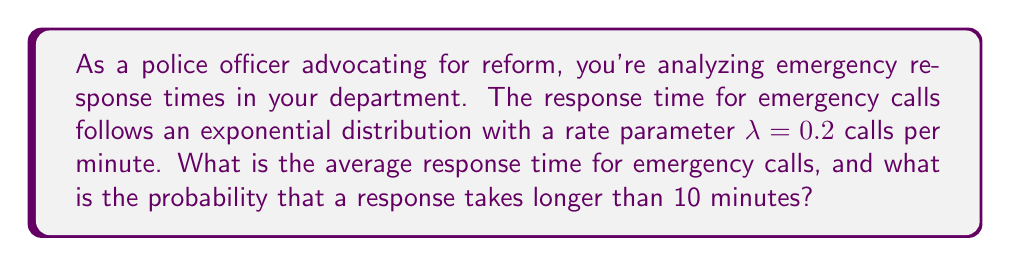Show me your answer to this math problem. To solve this problem, we need to use properties of the exponential distribution:

1. Average response time:
   For an exponential distribution, the mean (average) is given by $\frac{1}{\lambda}$.
   
   Average response time = $\frac{1}{\lambda} = \frac{1}{0.2} = 5$ minutes

2. Probability of response taking longer than 10 minutes:
   For an exponential distribution, the probability of an event taking longer than a specific time $t$ is given by:
   
   $P(X > t) = e^{-\lambda t}$

   In this case, $t = 10$ minutes and $\lambda = 0.2$

   $P(X > 10) = e^{-0.2 * 10} = e^{-2} \approx 0.1353$

To calculate this:
$$e^{-2} \approx 0.1353$$

This means there's approximately a 13.53% chance that a response will take longer than 10 minutes.
Answer: The average response time is 5 minutes, and the probability that a response takes longer than 10 minutes is approximately 0.1353 or 13.53%. 